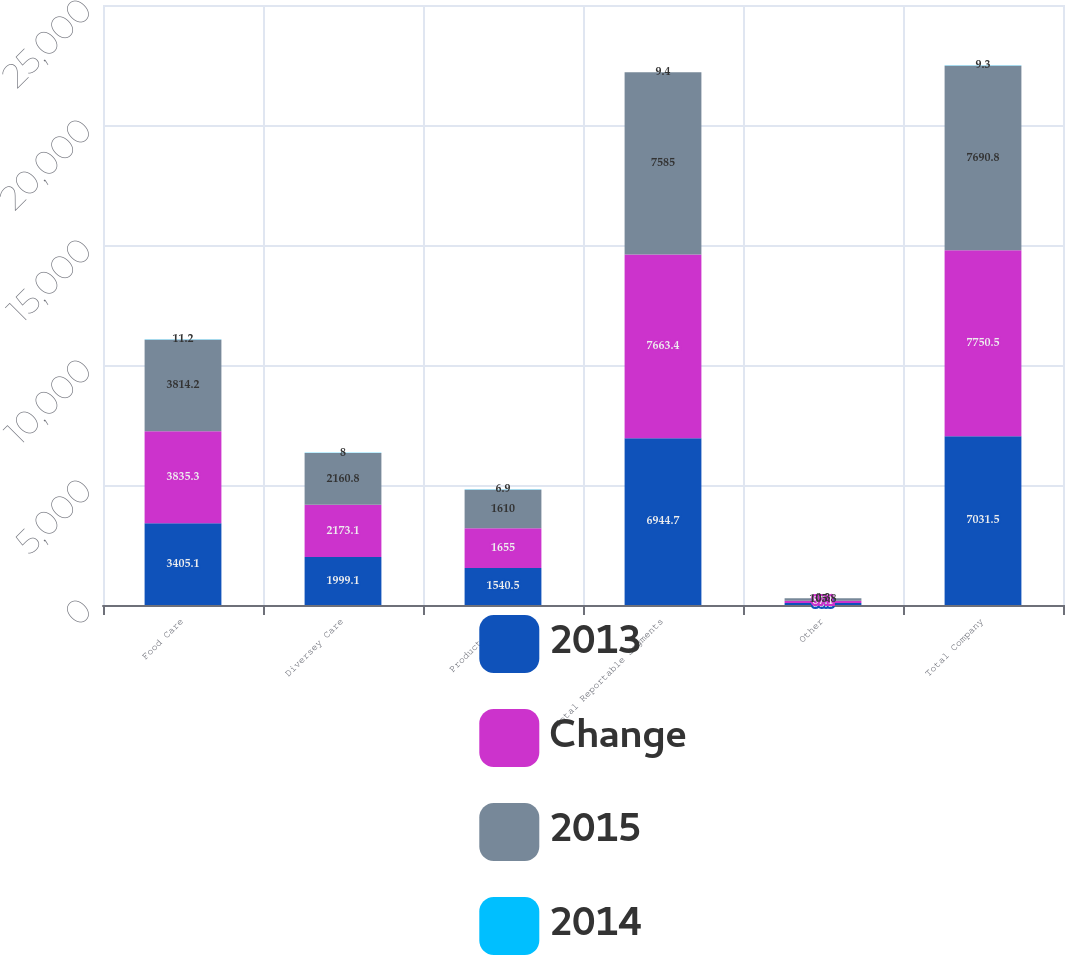Convert chart. <chart><loc_0><loc_0><loc_500><loc_500><stacked_bar_chart><ecel><fcel>Food Care<fcel>Diversey Care<fcel>Product Care<fcel>Total Reportable Segments<fcel>Other<fcel>Total Company<nl><fcel>2013<fcel>3405.1<fcel>1999.1<fcel>1540.5<fcel>6944.7<fcel>86.8<fcel>7031.5<nl><fcel>Change<fcel>3835.3<fcel>2173.1<fcel>1655<fcel>7663.4<fcel>87.1<fcel>7750.5<nl><fcel>2015<fcel>3814.2<fcel>2160.8<fcel>1610<fcel>7585<fcel>105.8<fcel>7690.8<nl><fcel>2014<fcel>11.2<fcel>8<fcel>6.9<fcel>9.4<fcel>0.3<fcel>9.3<nl></chart> 